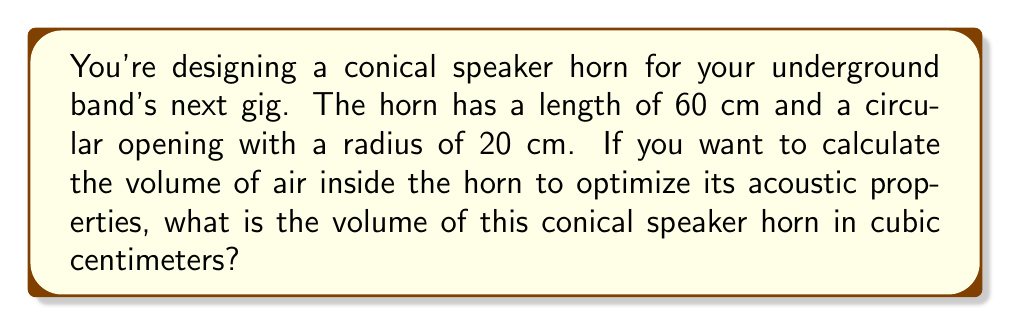Solve this math problem. To solve this problem, we'll use the formula for the volume of a cone:

$$V = \frac{1}{3}\pi r^2 h$$

Where:
$V$ = volume of the cone
$r$ = radius of the base
$h$ = height (length) of the cone

Given:
- Length of the horn (height of the cone) $h = 60$ cm
- Radius of the circular opening $r = 20$ cm

Let's substitute these values into the formula:

$$V = \frac{1}{3}\pi (20\text{ cm})^2 (60\text{ cm})$$

Simplify:
$$V = \frac{1}{3}\pi (400\text{ cm}^2) (60\text{ cm})$$
$$V = \frac{1}{3}\pi (24000\text{ cm}^3)$$

Calculate:
$$V \approx 25132.74\text{ cm}^3$$

[asy]
import geometry;

size(200);
pair A = (0,0), B = (4,0), C = (0,6);
draw(A--B--C--A);
draw(arc(B,0.5,0,90),dashed);
label("60 cm",C--A,W);
label("20 cm",B,S);
[/asy]

Rounding to the nearest cubic centimeter:
$$V \approx 25133\text{ cm}^3$$
Answer: $25133\text{ cm}^3$ 